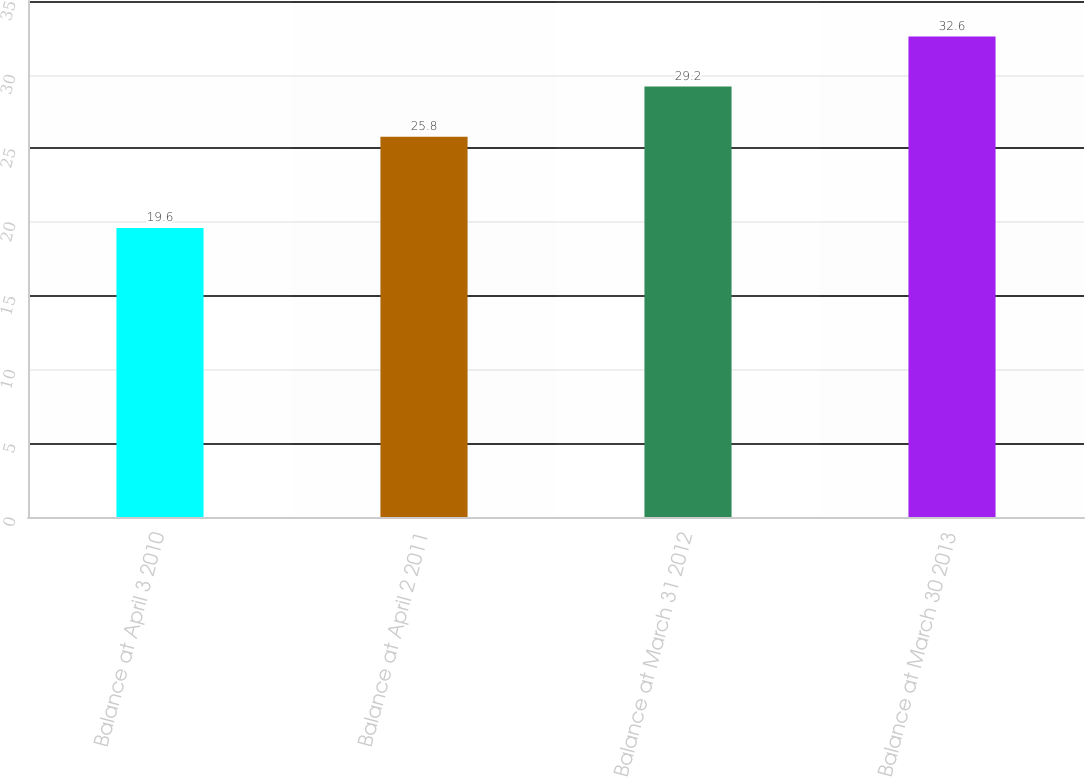Convert chart to OTSL. <chart><loc_0><loc_0><loc_500><loc_500><bar_chart><fcel>Balance at April 3 2010<fcel>Balance at April 2 2011<fcel>Balance at March 31 2012<fcel>Balance at March 30 2013<nl><fcel>19.6<fcel>25.8<fcel>29.2<fcel>32.6<nl></chart> 